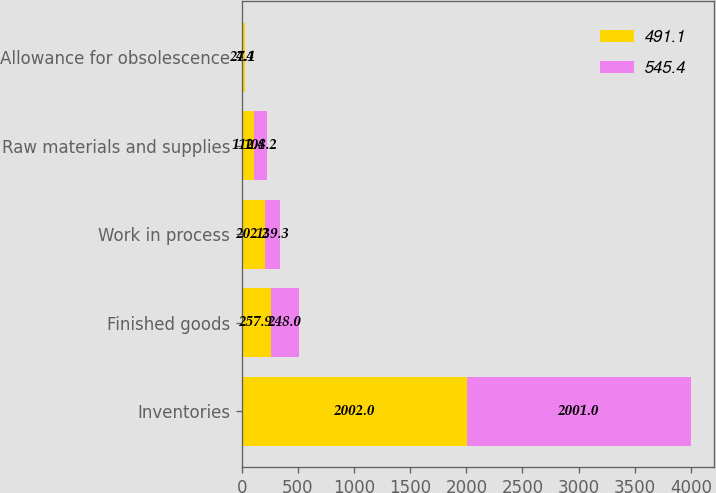<chart> <loc_0><loc_0><loc_500><loc_500><stacked_bar_chart><ecel><fcel>Inventories<fcel>Finished goods<fcel>Work in process<fcel>Raw materials and supplies<fcel>Allowance for obsolescence<nl><fcel>491.1<fcel>2002<fcel>257.9<fcel>202.2<fcel>112.4<fcel>27.1<nl><fcel>545.4<fcel>2001<fcel>248<fcel>139.3<fcel>108.2<fcel>4.4<nl></chart> 